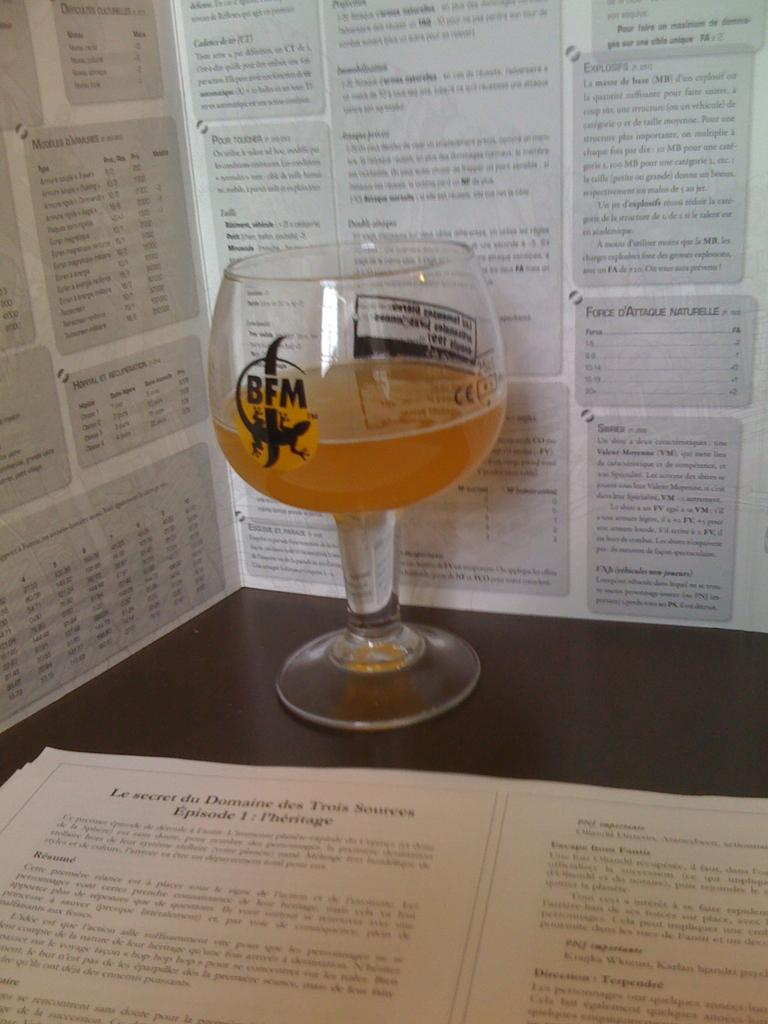What is inside the glass that is visible in the image? There is a drink in the glass in the image. What is at the bottom of the glass? There is a paper at the bottom of the glass. What is written on the paper? The paper has some script on it. What can be seen in the background of the image? There is a wall in the background of the image. What is on the wall? There are articles on the wall. What type of business does the girl in the image manage? There is no girl present in the image, so it is not possible to determine who manages a business. 